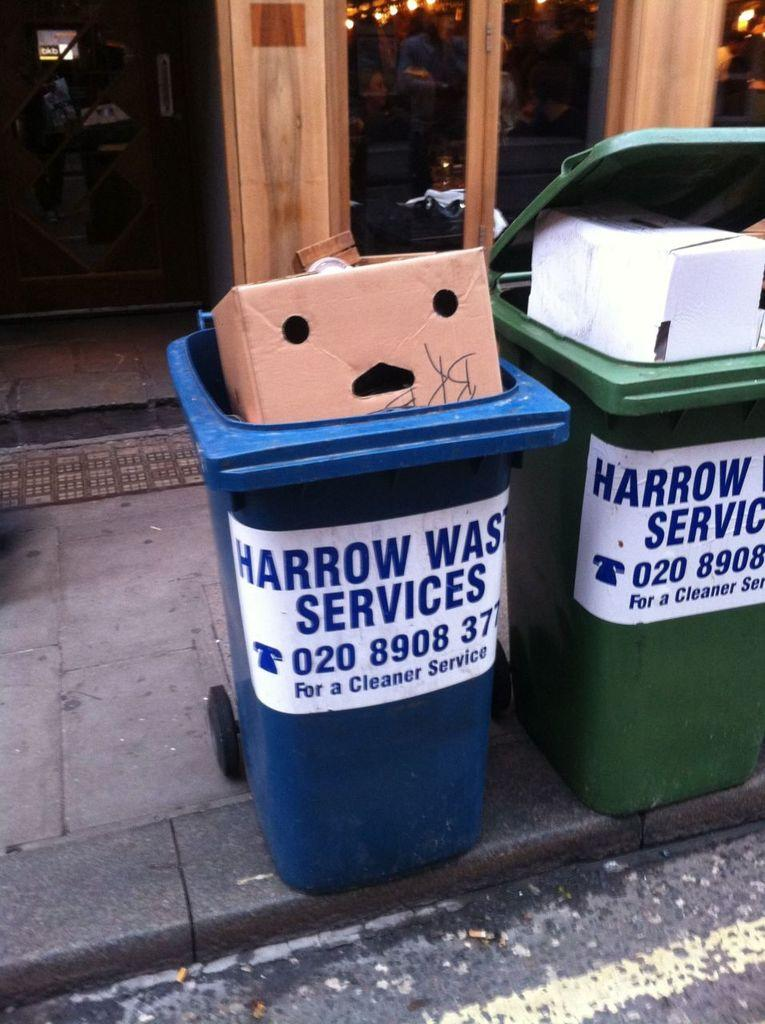<image>
Render a clear and concise summary of the photo. Two trash cans are side by side and say Harrow Waste Services on them. 